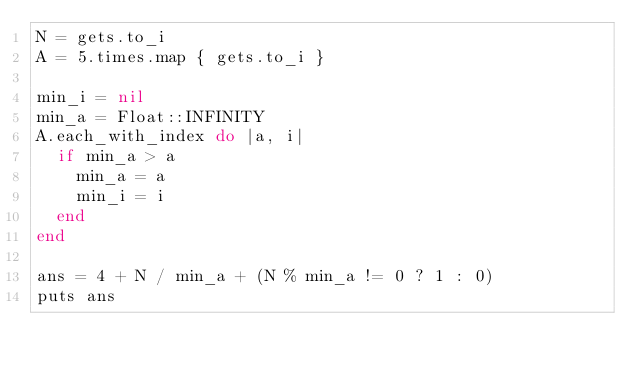<code> <loc_0><loc_0><loc_500><loc_500><_Ruby_>N = gets.to_i
A = 5.times.map { gets.to_i }

min_i = nil
min_a = Float::INFINITY
A.each_with_index do |a, i|
  if min_a > a
    min_a = a
    min_i = i
  end
end

ans = 4 + N / min_a + (N % min_a != 0 ? 1 : 0)
puts ans
</code> 